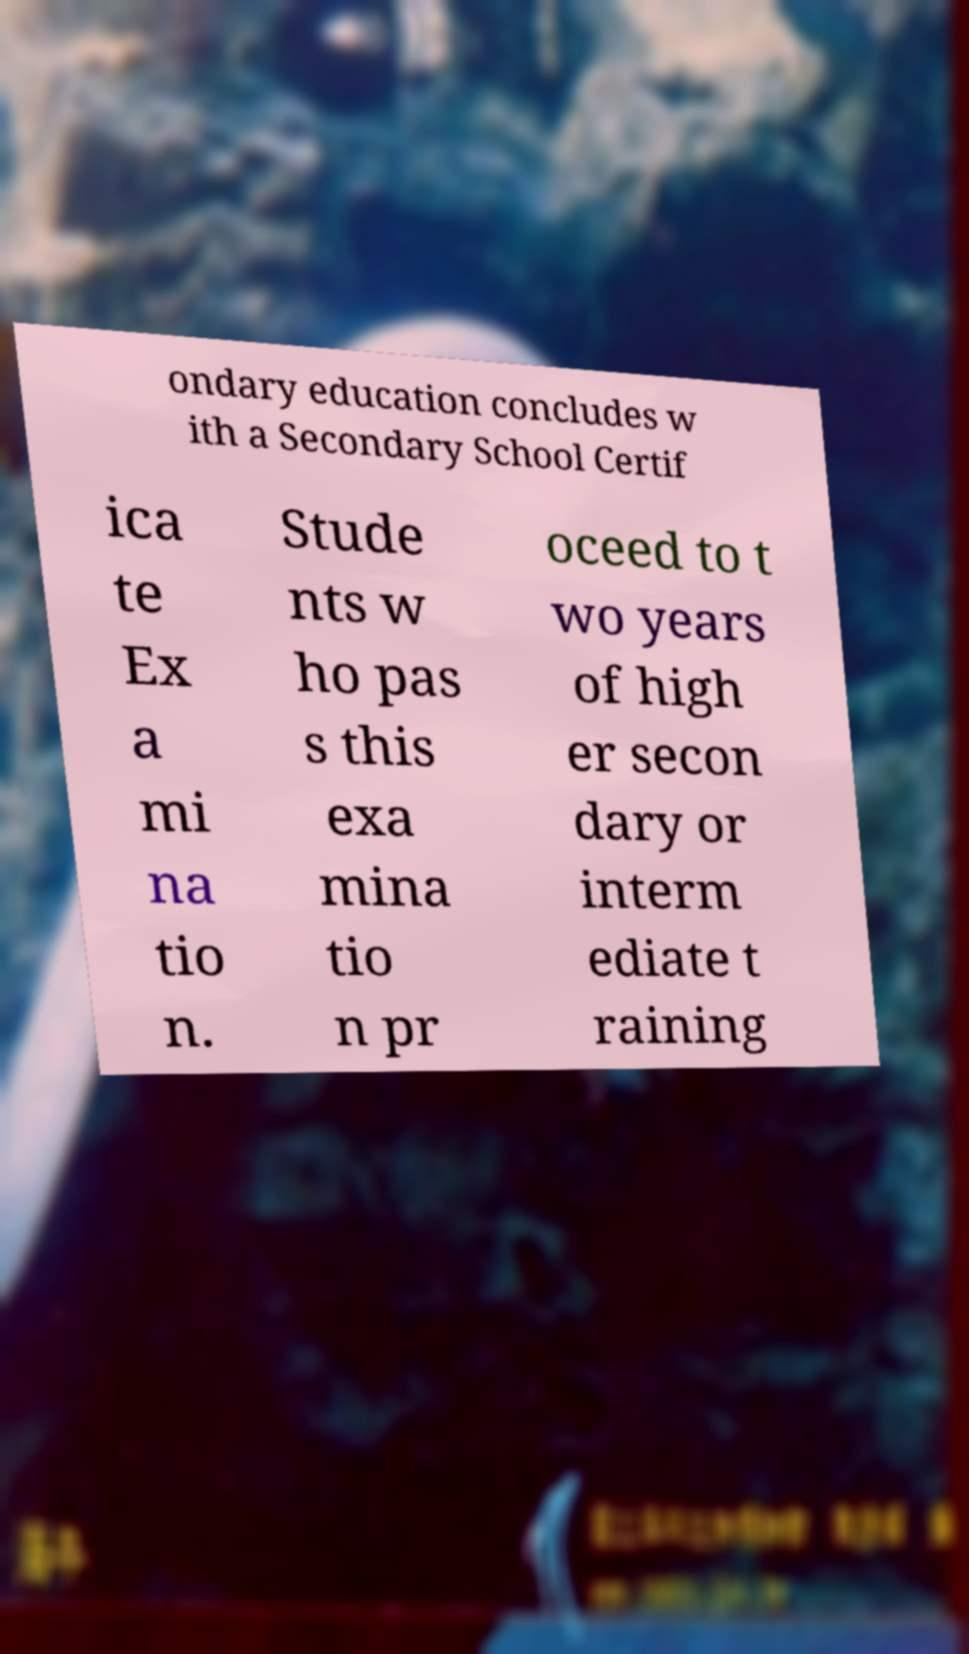I need the written content from this picture converted into text. Can you do that? ondary education concludes w ith a Secondary School Certif ica te Ex a mi na tio n. Stude nts w ho pas s this exa mina tio n pr oceed to t wo years of high er secon dary or interm ediate t raining 